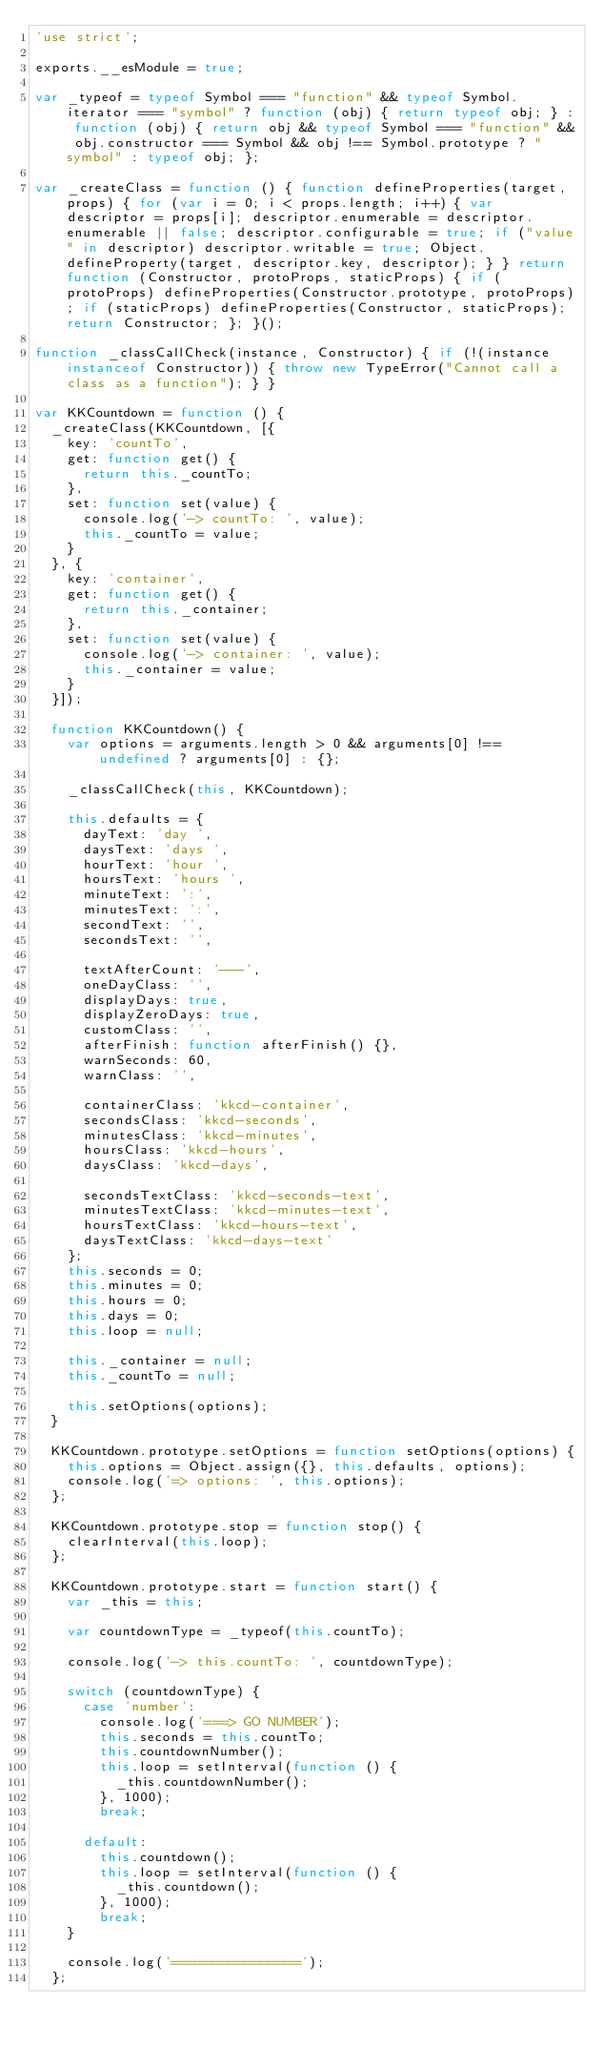<code> <loc_0><loc_0><loc_500><loc_500><_JavaScript_>'use strict';

exports.__esModule = true;

var _typeof = typeof Symbol === "function" && typeof Symbol.iterator === "symbol" ? function (obj) { return typeof obj; } : function (obj) { return obj && typeof Symbol === "function" && obj.constructor === Symbol && obj !== Symbol.prototype ? "symbol" : typeof obj; };

var _createClass = function () { function defineProperties(target, props) { for (var i = 0; i < props.length; i++) { var descriptor = props[i]; descriptor.enumerable = descriptor.enumerable || false; descriptor.configurable = true; if ("value" in descriptor) descriptor.writable = true; Object.defineProperty(target, descriptor.key, descriptor); } } return function (Constructor, protoProps, staticProps) { if (protoProps) defineProperties(Constructor.prototype, protoProps); if (staticProps) defineProperties(Constructor, staticProps); return Constructor; }; }();

function _classCallCheck(instance, Constructor) { if (!(instance instanceof Constructor)) { throw new TypeError("Cannot call a class as a function"); } }

var KKCountdown = function () {
  _createClass(KKCountdown, [{
    key: 'countTo',
    get: function get() {
      return this._countTo;
    },
    set: function set(value) {
      console.log('-> countTo: ', value);
      this._countTo = value;
    }
  }, {
    key: 'container',
    get: function get() {
      return this._container;
    },
    set: function set(value) {
      console.log('-> container: ', value);
      this._container = value;
    }
  }]);

  function KKCountdown() {
    var options = arguments.length > 0 && arguments[0] !== undefined ? arguments[0] : {};

    _classCallCheck(this, KKCountdown);

    this.defaults = {
      dayText: 'day ',
      daysText: 'days ',
      hourText: 'hour ',
      hoursText: 'hours ',
      minuteText: ':',
      minutesText: ':',
      secondText: '',
      secondsText: '',

      textAfterCount: '---',
      oneDayClass: '',
      displayDays: true,
      displayZeroDays: true,
      customClass: '',
      afterFinish: function afterFinish() {},
      warnSeconds: 60,
      warnClass: '',

      containerClass: 'kkcd-container',
      secondsClass: 'kkcd-seconds',
      minutesClass: 'kkcd-minutes',
      hoursClass: 'kkcd-hours',
      daysClass: 'kkcd-days',

      secondsTextClass: 'kkcd-seconds-text',
      minutesTextClass: 'kkcd-minutes-text',
      hoursTextClass: 'kkcd-hours-text',
      daysTextClass: 'kkcd-days-text'
    };
    this.seconds = 0;
    this.minutes = 0;
    this.hours = 0;
    this.days = 0;
    this.loop = null;

    this._container = null;
    this._countTo = null;

    this.setOptions(options);
  }

  KKCountdown.prototype.setOptions = function setOptions(options) {
    this.options = Object.assign({}, this.defaults, options);
    console.log('=> options: ', this.options);
  };

  KKCountdown.prototype.stop = function stop() {
    clearInterval(this.loop);
  };

  KKCountdown.prototype.start = function start() {
    var _this = this;

    var countdownType = _typeof(this.countTo);

    console.log('-> this.countTo: ', countdownType);

    switch (countdownType) {
      case 'number':
        console.log('===> GO NUMBER');
        this.seconds = this.countTo;
        this.countdownNumber();
        this.loop = setInterval(function () {
          _this.countdownNumber();
        }, 1000);
        break;

      default:
        this.countdown();
        this.loop = setInterval(function () {
          _this.countdown();
        }, 1000);
        break;
    }

    console.log('================');
  };
</code> 